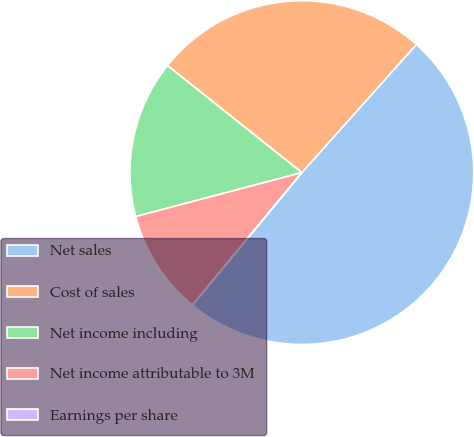Convert chart. <chart><loc_0><loc_0><loc_500><loc_500><pie_chart><fcel>Net sales<fcel>Cost of sales<fcel>Net income including<fcel>Net income attributable to 3M<fcel>Earnings per share<nl><fcel>49.38%<fcel>25.9%<fcel>14.82%<fcel>9.89%<fcel>0.01%<nl></chart> 